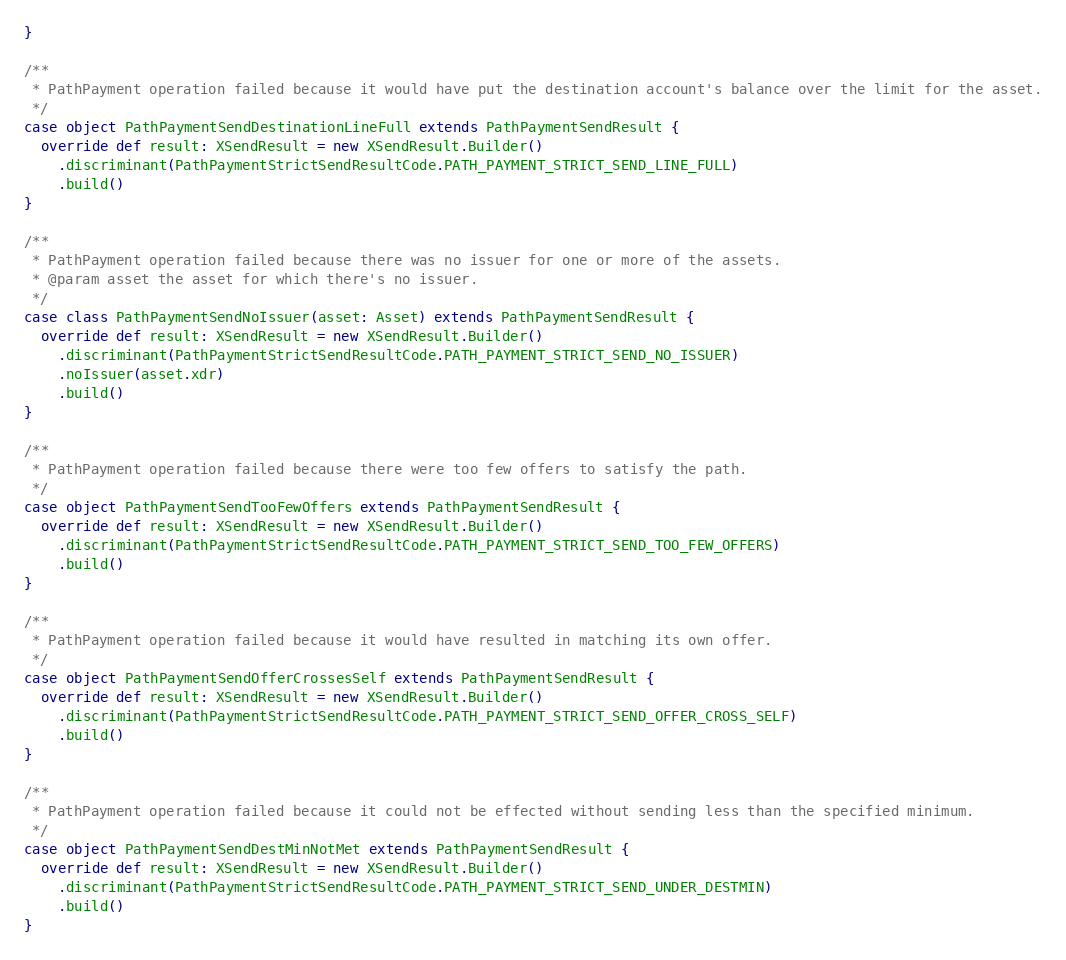Convert code to text. <code><loc_0><loc_0><loc_500><loc_500><_Scala_>}

/**
 * PathPayment operation failed because it would have put the destination account's balance over the limit for the asset.
 */
case object PathPaymentSendDestinationLineFull extends PathPaymentSendResult {
  override def result: XSendResult = new XSendResult.Builder()
    .discriminant(PathPaymentStrictSendResultCode.PATH_PAYMENT_STRICT_SEND_LINE_FULL)
    .build()
}

/**
 * PathPayment operation failed because there was no issuer for one or more of the assets.
 * @param asset the asset for which there's no issuer.
 */
case class PathPaymentSendNoIssuer(asset: Asset) extends PathPaymentSendResult {
  override def result: XSendResult = new XSendResult.Builder()
    .discriminant(PathPaymentStrictSendResultCode.PATH_PAYMENT_STRICT_SEND_NO_ISSUER)
    .noIssuer(asset.xdr)
    .build()
}

/**
 * PathPayment operation failed because there were too few offers to satisfy the path.
 */
case object PathPaymentSendTooFewOffers extends PathPaymentSendResult {
  override def result: XSendResult = new XSendResult.Builder()
    .discriminant(PathPaymentStrictSendResultCode.PATH_PAYMENT_STRICT_SEND_TOO_FEW_OFFERS)
    .build()
}

/**
 * PathPayment operation failed because it would have resulted in matching its own offer.
 */
case object PathPaymentSendOfferCrossesSelf extends PathPaymentSendResult {
  override def result: XSendResult = new XSendResult.Builder()
    .discriminant(PathPaymentStrictSendResultCode.PATH_PAYMENT_STRICT_SEND_OFFER_CROSS_SELF)
    .build()
}

/**
 * PathPayment operation failed because it could not be effected without sending less than the specified minimum.
 */
case object PathPaymentSendDestMinNotMet extends PathPaymentSendResult {
  override def result: XSendResult = new XSendResult.Builder()
    .discriminant(PathPaymentStrictSendResultCode.PATH_PAYMENT_STRICT_SEND_UNDER_DESTMIN)
    .build()
}</code> 